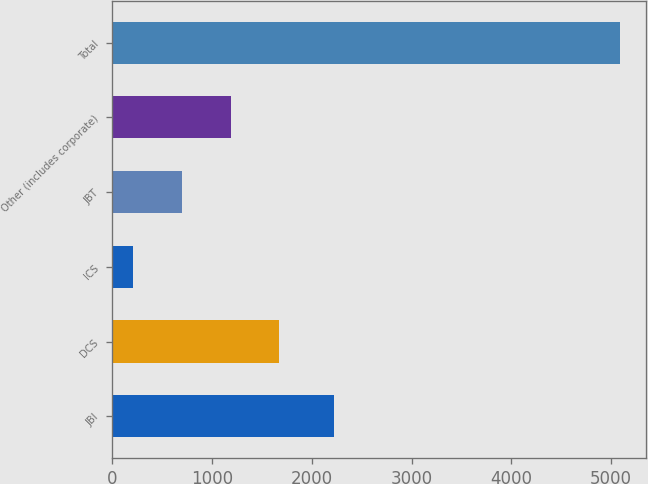<chart> <loc_0><loc_0><loc_500><loc_500><bar_chart><fcel>JBI<fcel>DCS<fcel>ICS<fcel>JBT<fcel>Other (includes corporate)<fcel>Total<nl><fcel>2221<fcel>1676<fcel>212<fcel>700<fcel>1188<fcel>5092<nl></chart> 